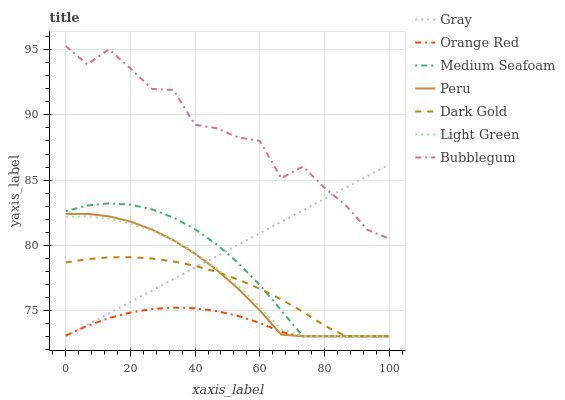Does Orange Red have the minimum area under the curve?
Answer yes or no. Yes. Does Bubblegum have the maximum area under the curve?
Answer yes or no. Yes. Does Peru have the minimum area under the curve?
Answer yes or no. No. Does Peru have the maximum area under the curve?
Answer yes or no. No. Is Gray the smoothest?
Answer yes or no. Yes. Is Bubblegum the roughest?
Answer yes or no. Yes. Is Peru the smoothest?
Answer yes or no. No. Is Peru the roughest?
Answer yes or no. No. Does Gray have the lowest value?
Answer yes or no. Yes. Does Bubblegum have the lowest value?
Answer yes or no. No. Does Bubblegum have the highest value?
Answer yes or no. Yes. Does Peru have the highest value?
Answer yes or no. No. Is Light Green less than Bubblegum?
Answer yes or no. Yes. Is Bubblegum greater than Light Green?
Answer yes or no. Yes. Does Peru intersect Light Green?
Answer yes or no. Yes. Is Peru less than Light Green?
Answer yes or no. No. Is Peru greater than Light Green?
Answer yes or no. No. Does Light Green intersect Bubblegum?
Answer yes or no. No. 